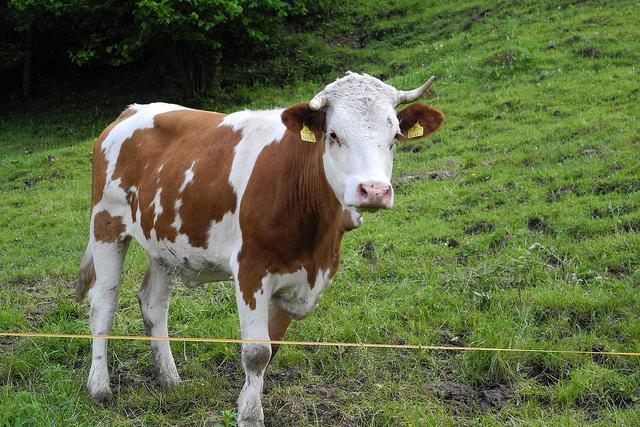What color is the grass?
Quick response, please. Green. Is this a pony?
Give a very brief answer. No. Is the cow standing?
Short answer required. Yes. How many cows are there?
Give a very brief answer. 1. Is the cow wild of farm?
Concise answer only. Farm. What color is the cow?
Give a very brief answer. Brown and white. 